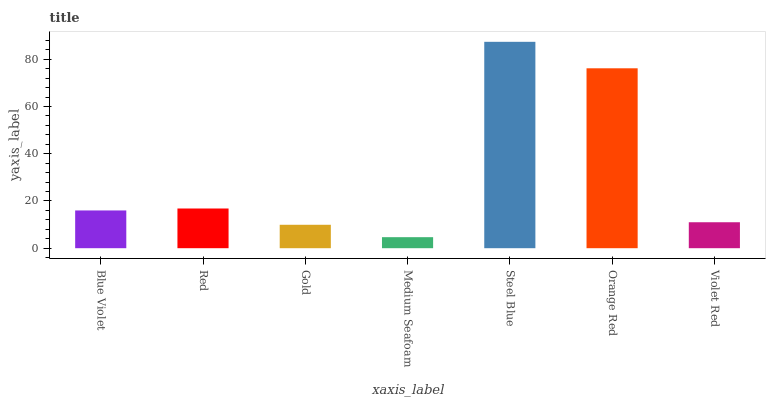Is Medium Seafoam the minimum?
Answer yes or no. Yes. Is Steel Blue the maximum?
Answer yes or no. Yes. Is Red the minimum?
Answer yes or no. No. Is Red the maximum?
Answer yes or no. No. Is Red greater than Blue Violet?
Answer yes or no. Yes. Is Blue Violet less than Red?
Answer yes or no. Yes. Is Blue Violet greater than Red?
Answer yes or no. No. Is Red less than Blue Violet?
Answer yes or no. No. Is Blue Violet the high median?
Answer yes or no. Yes. Is Blue Violet the low median?
Answer yes or no. Yes. Is Violet Red the high median?
Answer yes or no. No. Is Orange Red the low median?
Answer yes or no. No. 